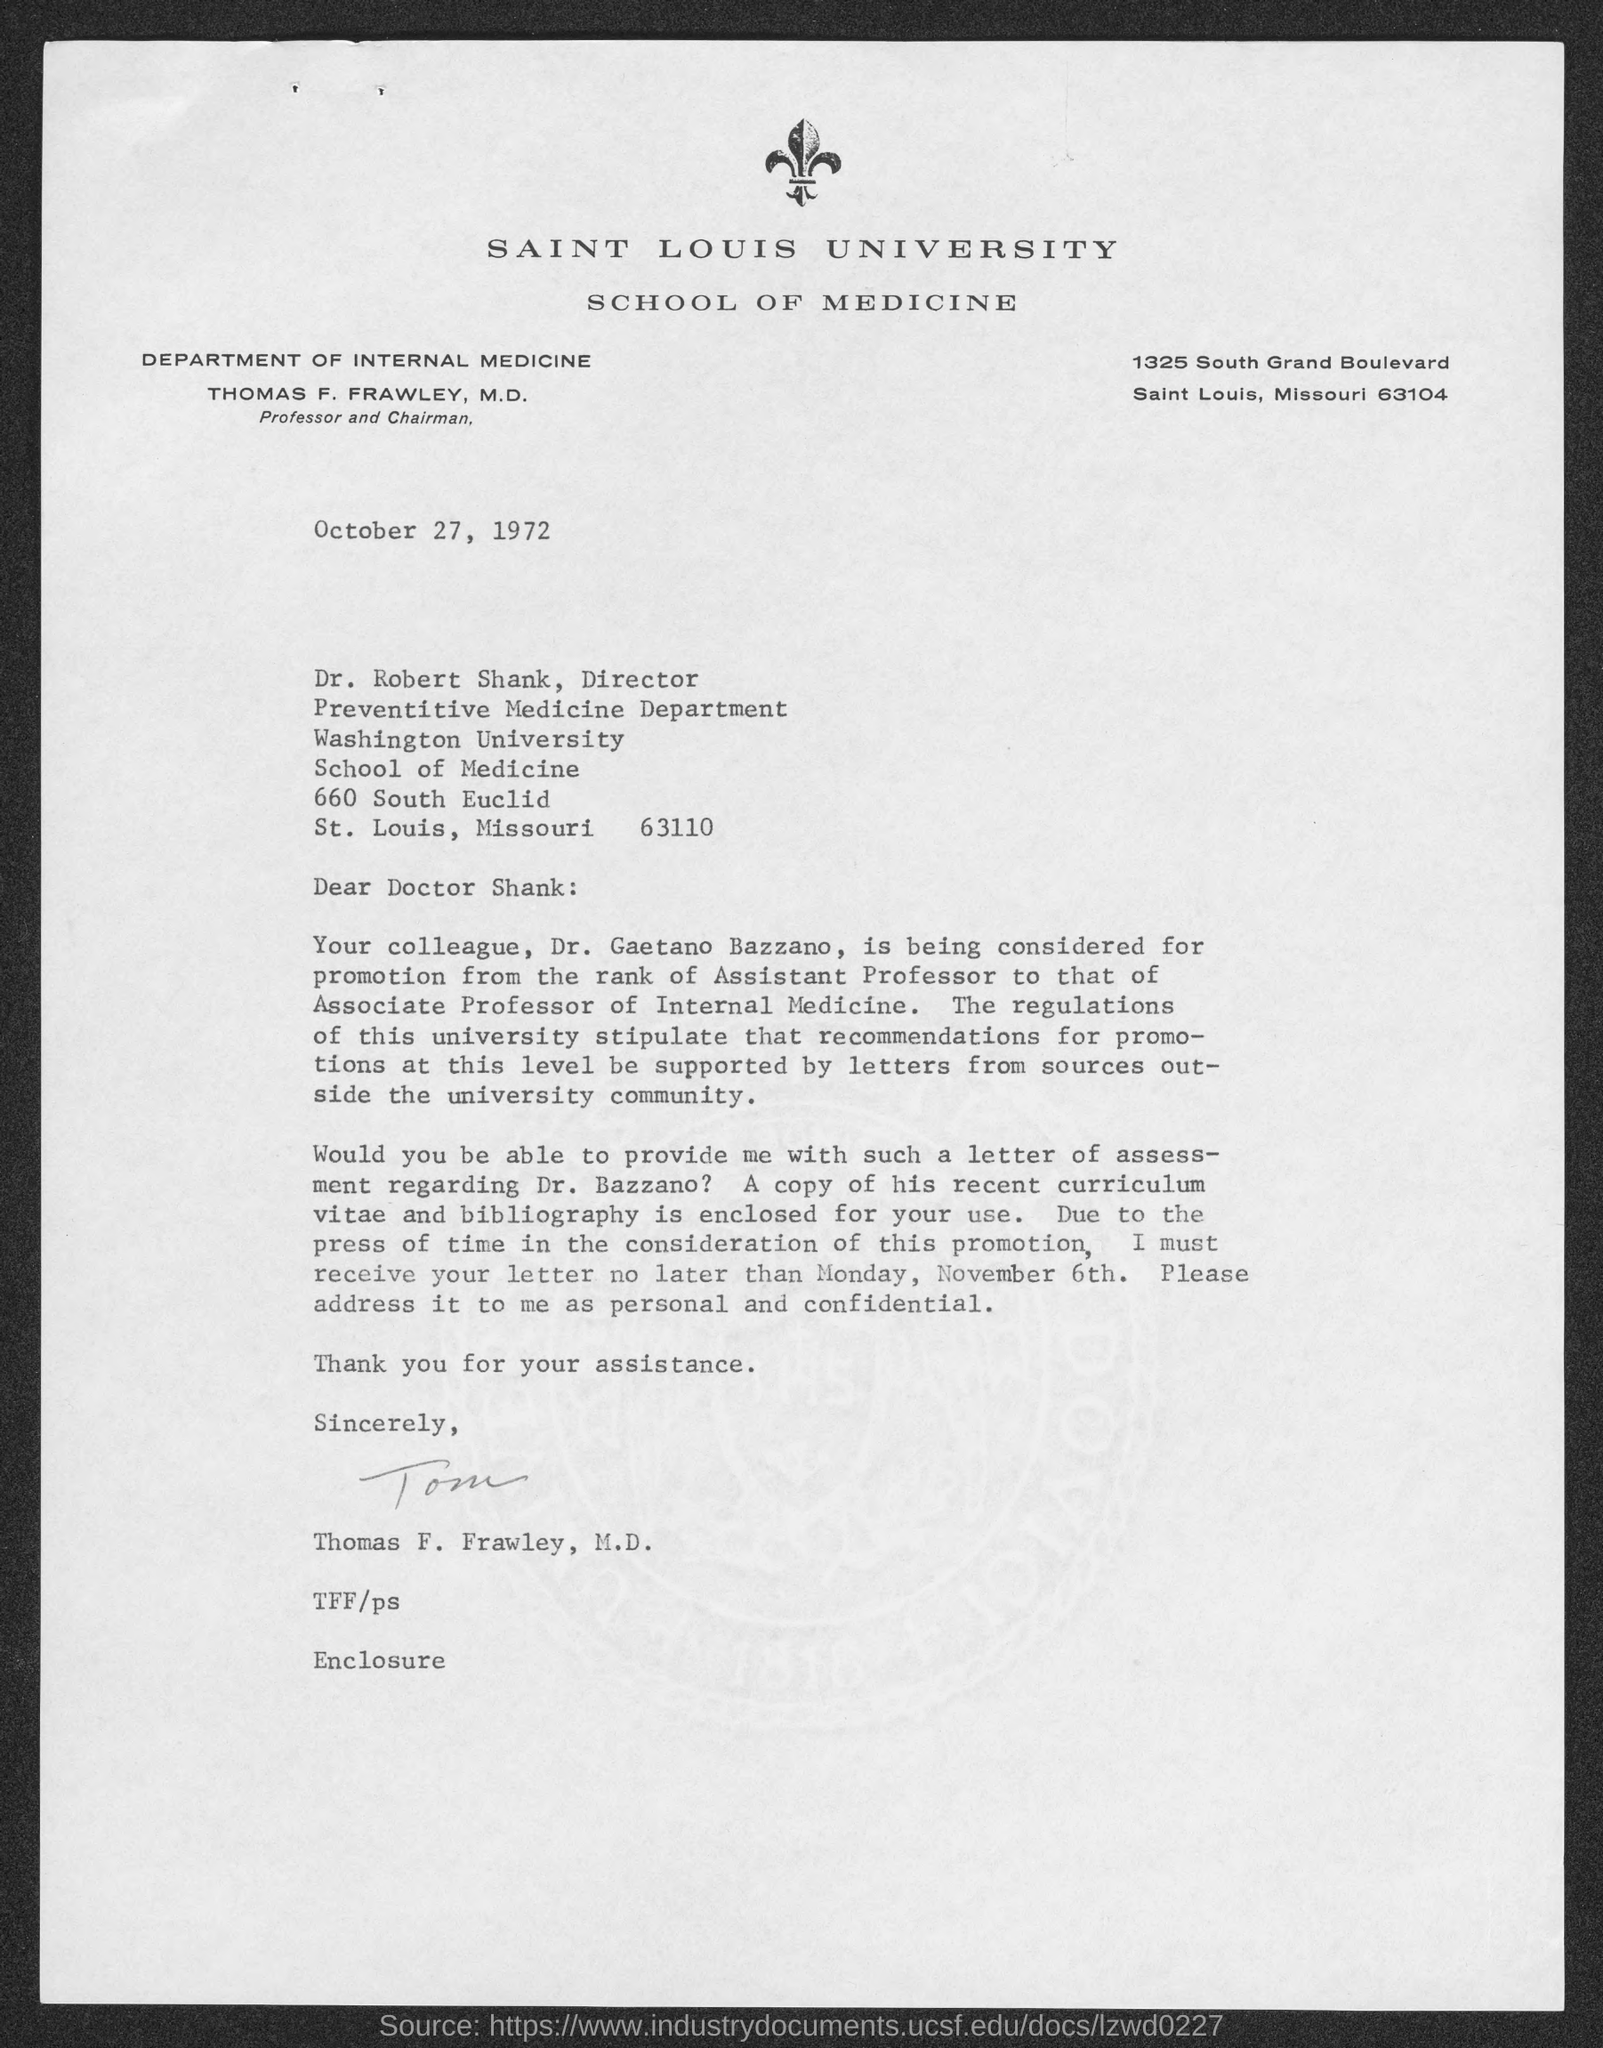Give some essential details in this illustration. The addressee of this letter is Dr. Robert Shank. Dr. Robert Shank holds the designation of Director of the Preventive Medicine Department. The sender of this letter is Thomas F. Frawley, M.D. Thomas F. Frawley, M.D., holds the designation of Professor and Chairman of the DEPARTMENT OF INTERNAL MEDICINE. Saint Louis University is mentioned in the letterhead. 